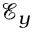Convert formula to latex. <formula><loc_0><loc_0><loc_500><loc_500>\mathcal { E } _ { y }</formula> 